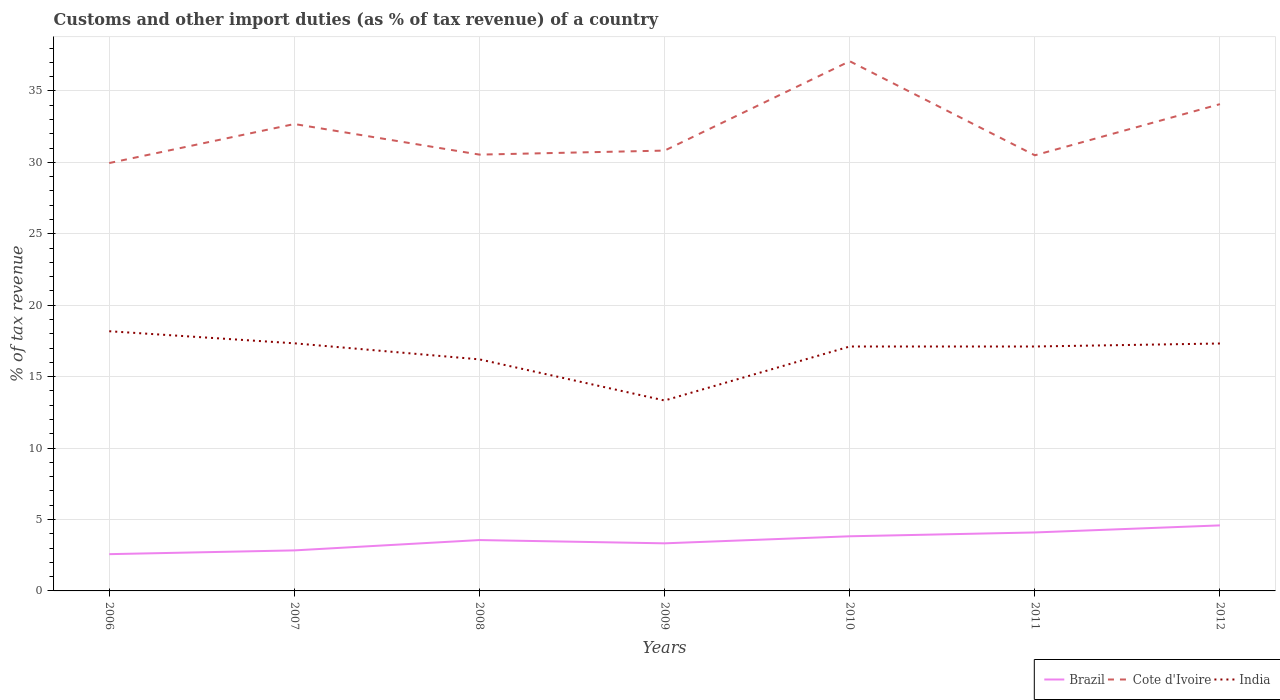Across all years, what is the maximum percentage of tax revenue from customs in Brazil?
Ensure brevity in your answer.  2.57. What is the total percentage of tax revenue from customs in Cote d'Ivoire in the graph?
Ensure brevity in your answer.  -1.39. What is the difference between the highest and the second highest percentage of tax revenue from customs in Brazil?
Provide a succinct answer. 2.01. What is the difference between two consecutive major ticks on the Y-axis?
Your response must be concise. 5. Does the graph contain any zero values?
Provide a succinct answer. No. Does the graph contain grids?
Offer a terse response. Yes. Where does the legend appear in the graph?
Offer a terse response. Bottom right. How many legend labels are there?
Ensure brevity in your answer.  3. How are the legend labels stacked?
Make the answer very short. Horizontal. What is the title of the graph?
Offer a terse response. Customs and other import duties (as % of tax revenue) of a country. What is the label or title of the Y-axis?
Keep it short and to the point. % of tax revenue. What is the % of tax revenue of Brazil in 2006?
Your answer should be very brief. 2.57. What is the % of tax revenue of Cote d'Ivoire in 2006?
Provide a short and direct response. 29.95. What is the % of tax revenue in India in 2006?
Ensure brevity in your answer.  18.18. What is the % of tax revenue in Brazil in 2007?
Your answer should be very brief. 2.84. What is the % of tax revenue in Cote d'Ivoire in 2007?
Offer a terse response. 32.68. What is the % of tax revenue of India in 2007?
Your answer should be very brief. 17.33. What is the % of tax revenue in Brazil in 2008?
Offer a very short reply. 3.56. What is the % of tax revenue of Cote d'Ivoire in 2008?
Ensure brevity in your answer.  30.54. What is the % of tax revenue in India in 2008?
Ensure brevity in your answer.  16.21. What is the % of tax revenue in Brazil in 2009?
Ensure brevity in your answer.  3.33. What is the % of tax revenue in Cote d'Ivoire in 2009?
Give a very brief answer. 30.82. What is the % of tax revenue of India in 2009?
Your answer should be very brief. 13.33. What is the % of tax revenue in Brazil in 2010?
Your answer should be very brief. 3.82. What is the % of tax revenue of Cote d'Ivoire in 2010?
Ensure brevity in your answer.  37.08. What is the % of tax revenue of India in 2010?
Your response must be concise. 17.11. What is the % of tax revenue in Brazil in 2011?
Provide a succinct answer. 4.09. What is the % of tax revenue in Cote d'Ivoire in 2011?
Give a very brief answer. 30.49. What is the % of tax revenue in India in 2011?
Your answer should be very brief. 17.11. What is the % of tax revenue in Brazil in 2012?
Provide a succinct answer. 4.59. What is the % of tax revenue in Cote d'Ivoire in 2012?
Provide a succinct answer. 34.07. What is the % of tax revenue of India in 2012?
Offer a terse response. 17.32. Across all years, what is the maximum % of tax revenue in Brazil?
Offer a very short reply. 4.59. Across all years, what is the maximum % of tax revenue in Cote d'Ivoire?
Keep it short and to the point. 37.08. Across all years, what is the maximum % of tax revenue in India?
Your answer should be very brief. 18.18. Across all years, what is the minimum % of tax revenue in Brazil?
Your answer should be compact. 2.57. Across all years, what is the minimum % of tax revenue in Cote d'Ivoire?
Provide a succinct answer. 29.95. Across all years, what is the minimum % of tax revenue in India?
Your answer should be very brief. 13.33. What is the total % of tax revenue in Brazil in the graph?
Ensure brevity in your answer.  24.8. What is the total % of tax revenue of Cote d'Ivoire in the graph?
Ensure brevity in your answer.  225.62. What is the total % of tax revenue in India in the graph?
Offer a very short reply. 116.58. What is the difference between the % of tax revenue in Brazil in 2006 and that in 2007?
Make the answer very short. -0.26. What is the difference between the % of tax revenue of Cote d'Ivoire in 2006 and that in 2007?
Make the answer very short. -2.73. What is the difference between the % of tax revenue in India in 2006 and that in 2007?
Make the answer very short. 0.85. What is the difference between the % of tax revenue of Brazil in 2006 and that in 2008?
Ensure brevity in your answer.  -0.99. What is the difference between the % of tax revenue in Cote d'Ivoire in 2006 and that in 2008?
Offer a terse response. -0.59. What is the difference between the % of tax revenue in India in 2006 and that in 2008?
Keep it short and to the point. 1.97. What is the difference between the % of tax revenue in Brazil in 2006 and that in 2009?
Offer a terse response. -0.76. What is the difference between the % of tax revenue of Cote d'Ivoire in 2006 and that in 2009?
Give a very brief answer. -0.87. What is the difference between the % of tax revenue in India in 2006 and that in 2009?
Make the answer very short. 4.85. What is the difference between the % of tax revenue in Brazil in 2006 and that in 2010?
Your response must be concise. -1.25. What is the difference between the % of tax revenue of Cote d'Ivoire in 2006 and that in 2010?
Offer a very short reply. -7.13. What is the difference between the % of tax revenue in India in 2006 and that in 2010?
Provide a succinct answer. 1.07. What is the difference between the % of tax revenue of Brazil in 2006 and that in 2011?
Your answer should be very brief. -1.52. What is the difference between the % of tax revenue of Cote d'Ivoire in 2006 and that in 2011?
Your answer should be compact. -0.54. What is the difference between the % of tax revenue in India in 2006 and that in 2011?
Your answer should be very brief. 1.07. What is the difference between the % of tax revenue of Brazil in 2006 and that in 2012?
Your response must be concise. -2.01. What is the difference between the % of tax revenue of Cote d'Ivoire in 2006 and that in 2012?
Provide a succinct answer. -4.12. What is the difference between the % of tax revenue in India in 2006 and that in 2012?
Provide a short and direct response. 0.86. What is the difference between the % of tax revenue of Brazil in 2007 and that in 2008?
Give a very brief answer. -0.72. What is the difference between the % of tax revenue in Cote d'Ivoire in 2007 and that in 2008?
Provide a succinct answer. 2.14. What is the difference between the % of tax revenue of India in 2007 and that in 2008?
Provide a succinct answer. 1.12. What is the difference between the % of tax revenue in Brazil in 2007 and that in 2009?
Make the answer very short. -0.49. What is the difference between the % of tax revenue of Cote d'Ivoire in 2007 and that in 2009?
Give a very brief answer. 1.86. What is the difference between the % of tax revenue in India in 2007 and that in 2009?
Ensure brevity in your answer.  4. What is the difference between the % of tax revenue in Brazil in 2007 and that in 2010?
Offer a terse response. -0.99. What is the difference between the % of tax revenue in Cote d'Ivoire in 2007 and that in 2010?
Keep it short and to the point. -4.4. What is the difference between the % of tax revenue of India in 2007 and that in 2010?
Keep it short and to the point. 0.22. What is the difference between the % of tax revenue of Brazil in 2007 and that in 2011?
Your response must be concise. -1.26. What is the difference between the % of tax revenue of Cote d'Ivoire in 2007 and that in 2011?
Give a very brief answer. 2.19. What is the difference between the % of tax revenue in India in 2007 and that in 2011?
Offer a terse response. 0.22. What is the difference between the % of tax revenue in Brazil in 2007 and that in 2012?
Your answer should be compact. -1.75. What is the difference between the % of tax revenue in Cote d'Ivoire in 2007 and that in 2012?
Give a very brief answer. -1.39. What is the difference between the % of tax revenue of India in 2007 and that in 2012?
Your answer should be very brief. 0.01. What is the difference between the % of tax revenue of Brazil in 2008 and that in 2009?
Your answer should be very brief. 0.23. What is the difference between the % of tax revenue in Cote d'Ivoire in 2008 and that in 2009?
Your response must be concise. -0.28. What is the difference between the % of tax revenue in India in 2008 and that in 2009?
Provide a short and direct response. 2.88. What is the difference between the % of tax revenue in Brazil in 2008 and that in 2010?
Provide a short and direct response. -0.26. What is the difference between the % of tax revenue in Cote d'Ivoire in 2008 and that in 2010?
Your response must be concise. -6.54. What is the difference between the % of tax revenue of India in 2008 and that in 2010?
Ensure brevity in your answer.  -0.9. What is the difference between the % of tax revenue of Brazil in 2008 and that in 2011?
Your answer should be compact. -0.53. What is the difference between the % of tax revenue of Cote d'Ivoire in 2008 and that in 2011?
Give a very brief answer. 0.05. What is the difference between the % of tax revenue in India in 2008 and that in 2011?
Your answer should be very brief. -0.9. What is the difference between the % of tax revenue in Brazil in 2008 and that in 2012?
Your answer should be very brief. -1.03. What is the difference between the % of tax revenue in Cote d'Ivoire in 2008 and that in 2012?
Offer a very short reply. -3.53. What is the difference between the % of tax revenue of India in 2008 and that in 2012?
Offer a terse response. -1.11. What is the difference between the % of tax revenue of Brazil in 2009 and that in 2010?
Make the answer very short. -0.49. What is the difference between the % of tax revenue of Cote d'Ivoire in 2009 and that in 2010?
Offer a very short reply. -6.26. What is the difference between the % of tax revenue in India in 2009 and that in 2010?
Give a very brief answer. -3.78. What is the difference between the % of tax revenue of Brazil in 2009 and that in 2011?
Ensure brevity in your answer.  -0.76. What is the difference between the % of tax revenue in Cote d'Ivoire in 2009 and that in 2011?
Give a very brief answer. 0.33. What is the difference between the % of tax revenue in India in 2009 and that in 2011?
Your answer should be very brief. -3.78. What is the difference between the % of tax revenue of Brazil in 2009 and that in 2012?
Provide a succinct answer. -1.26. What is the difference between the % of tax revenue of Cote d'Ivoire in 2009 and that in 2012?
Your response must be concise. -3.25. What is the difference between the % of tax revenue of India in 2009 and that in 2012?
Your answer should be very brief. -3.99. What is the difference between the % of tax revenue in Brazil in 2010 and that in 2011?
Make the answer very short. -0.27. What is the difference between the % of tax revenue of Cote d'Ivoire in 2010 and that in 2011?
Offer a terse response. 6.58. What is the difference between the % of tax revenue in Brazil in 2010 and that in 2012?
Provide a succinct answer. -0.76. What is the difference between the % of tax revenue of Cote d'Ivoire in 2010 and that in 2012?
Your response must be concise. 3. What is the difference between the % of tax revenue in India in 2010 and that in 2012?
Provide a succinct answer. -0.21. What is the difference between the % of tax revenue of Brazil in 2011 and that in 2012?
Offer a very short reply. -0.49. What is the difference between the % of tax revenue of Cote d'Ivoire in 2011 and that in 2012?
Provide a succinct answer. -3.58. What is the difference between the % of tax revenue of India in 2011 and that in 2012?
Ensure brevity in your answer.  -0.21. What is the difference between the % of tax revenue of Brazil in 2006 and the % of tax revenue of Cote d'Ivoire in 2007?
Your response must be concise. -30.11. What is the difference between the % of tax revenue of Brazil in 2006 and the % of tax revenue of India in 2007?
Make the answer very short. -14.76. What is the difference between the % of tax revenue of Cote d'Ivoire in 2006 and the % of tax revenue of India in 2007?
Offer a terse response. 12.62. What is the difference between the % of tax revenue of Brazil in 2006 and the % of tax revenue of Cote d'Ivoire in 2008?
Your answer should be compact. -27.96. What is the difference between the % of tax revenue of Brazil in 2006 and the % of tax revenue of India in 2008?
Your answer should be very brief. -13.63. What is the difference between the % of tax revenue in Cote d'Ivoire in 2006 and the % of tax revenue in India in 2008?
Provide a short and direct response. 13.74. What is the difference between the % of tax revenue of Brazil in 2006 and the % of tax revenue of Cote d'Ivoire in 2009?
Provide a short and direct response. -28.25. What is the difference between the % of tax revenue of Brazil in 2006 and the % of tax revenue of India in 2009?
Your answer should be very brief. -10.76. What is the difference between the % of tax revenue of Cote d'Ivoire in 2006 and the % of tax revenue of India in 2009?
Provide a succinct answer. 16.62. What is the difference between the % of tax revenue in Brazil in 2006 and the % of tax revenue in Cote d'Ivoire in 2010?
Your answer should be very brief. -34.5. What is the difference between the % of tax revenue of Brazil in 2006 and the % of tax revenue of India in 2010?
Provide a short and direct response. -14.53. What is the difference between the % of tax revenue of Cote d'Ivoire in 2006 and the % of tax revenue of India in 2010?
Offer a very short reply. 12.84. What is the difference between the % of tax revenue in Brazil in 2006 and the % of tax revenue in Cote d'Ivoire in 2011?
Make the answer very short. -27.92. What is the difference between the % of tax revenue in Brazil in 2006 and the % of tax revenue in India in 2011?
Provide a succinct answer. -14.53. What is the difference between the % of tax revenue of Cote d'Ivoire in 2006 and the % of tax revenue of India in 2011?
Your answer should be compact. 12.84. What is the difference between the % of tax revenue of Brazil in 2006 and the % of tax revenue of Cote d'Ivoire in 2012?
Offer a terse response. -31.5. What is the difference between the % of tax revenue in Brazil in 2006 and the % of tax revenue in India in 2012?
Your answer should be compact. -14.74. What is the difference between the % of tax revenue in Cote d'Ivoire in 2006 and the % of tax revenue in India in 2012?
Give a very brief answer. 12.63. What is the difference between the % of tax revenue in Brazil in 2007 and the % of tax revenue in Cote d'Ivoire in 2008?
Make the answer very short. -27.7. What is the difference between the % of tax revenue in Brazil in 2007 and the % of tax revenue in India in 2008?
Your answer should be compact. -13.37. What is the difference between the % of tax revenue of Cote d'Ivoire in 2007 and the % of tax revenue of India in 2008?
Give a very brief answer. 16.47. What is the difference between the % of tax revenue in Brazil in 2007 and the % of tax revenue in Cote d'Ivoire in 2009?
Offer a very short reply. -27.98. What is the difference between the % of tax revenue of Brazil in 2007 and the % of tax revenue of India in 2009?
Your response must be concise. -10.49. What is the difference between the % of tax revenue in Cote d'Ivoire in 2007 and the % of tax revenue in India in 2009?
Make the answer very short. 19.35. What is the difference between the % of tax revenue in Brazil in 2007 and the % of tax revenue in Cote d'Ivoire in 2010?
Your response must be concise. -34.24. What is the difference between the % of tax revenue of Brazil in 2007 and the % of tax revenue of India in 2010?
Keep it short and to the point. -14.27. What is the difference between the % of tax revenue in Cote d'Ivoire in 2007 and the % of tax revenue in India in 2010?
Your response must be concise. 15.57. What is the difference between the % of tax revenue in Brazil in 2007 and the % of tax revenue in Cote d'Ivoire in 2011?
Ensure brevity in your answer.  -27.65. What is the difference between the % of tax revenue in Brazil in 2007 and the % of tax revenue in India in 2011?
Provide a succinct answer. -14.27. What is the difference between the % of tax revenue of Cote d'Ivoire in 2007 and the % of tax revenue of India in 2011?
Provide a short and direct response. 15.57. What is the difference between the % of tax revenue of Brazil in 2007 and the % of tax revenue of Cote d'Ivoire in 2012?
Provide a short and direct response. -31.23. What is the difference between the % of tax revenue in Brazil in 2007 and the % of tax revenue in India in 2012?
Ensure brevity in your answer.  -14.48. What is the difference between the % of tax revenue of Cote d'Ivoire in 2007 and the % of tax revenue of India in 2012?
Your answer should be very brief. 15.36. What is the difference between the % of tax revenue in Brazil in 2008 and the % of tax revenue in Cote d'Ivoire in 2009?
Make the answer very short. -27.26. What is the difference between the % of tax revenue in Brazil in 2008 and the % of tax revenue in India in 2009?
Give a very brief answer. -9.77. What is the difference between the % of tax revenue in Cote d'Ivoire in 2008 and the % of tax revenue in India in 2009?
Make the answer very short. 17.21. What is the difference between the % of tax revenue in Brazil in 2008 and the % of tax revenue in Cote d'Ivoire in 2010?
Keep it short and to the point. -33.52. What is the difference between the % of tax revenue in Brazil in 2008 and the % of tax revenue in India in 2010?
Give a very brief answer. -13.55. What is the difference between the % of tax revenue in Cote d'Ivoire in 2008 and the % of tax revenue in India in 2010?
Offer a terse response. 13.43. What is the difference between the % of tax revenue of Brazil in 2008 and the % of tax revenue of Cote d'Ivoire in 2011?
Offer a terse response. -26.93. What is the difference between the % of tax revenue of Brazil in 2008 and the % of tax revenue of India in 2011?
Keep it short and to the point. -13.55. What is the difference between the % of tax revenue in Cote d'Ivoire in 2008 and the % of tax revenue in India in 2011?
Keep it short and to the point. 13.43. What is the difference between the % of tax revenue in Brazil in 2008 and the % of tax revenue in Cote d'Ivoire in 2012?
Provide a succinct answer. -30.51. What is the difference between the % of tax revenue of Brazil in 2008 and the % of tax revenue of India in 2012?
Offer a very short reply. -13.76. What is the difference between the % of tax revenue of Cote d'Ivoire in 2008 and the % of tax revenue of India in 2012?
Your response must be concise. 13.22. What is the difference between the % of tax revenue of Brazil in 2009 and the % of tax revenue of Cote d'Ivoire in 2010?
Provide a succinct answer. -33.74. What is the difference between the % of tax revenue in Brazil in 2009 and the % of tax revenue in India in 2010?
Make the answer very short. -13.78. What is the difference between the % of tax revenue of Cote d'Ivoire in 2009 and the % of tax revenue of India in 2010?
Your answer should be compact. 13.71. What is the difference between the % of tax revenue in Brazil in 2009 and the % of tax revenue in Cote d'Ivoire in 2011?
Keep it short and to the point. -27.16. What is the difference between the % of tax revenue in Brazil in 2009 and the % of tax revenue in India in 2011?
Provide a succinct answer. -13.78. What is the difference between the % of tax revenue in Cote d'Ivoire in 2009 and the % of tax revenue in India in 2011?
Provide a short and direct response. 13.71. What is the difference between the % of tax revenue of Brazil in 2009 and the % of tax revenue of Cote d'Ivoire in 2012?
Your answer should be very brief. -30.74. What is the difference between the % of tax revenue of Brazil in 2009 and the % of tax revenue of India in 2012?
Ensure brevity in your answer.  -13.99. What is the difference between the % of tax revenue of Cote d'Ivoire in 2009 and the % of tax revenue of India in 2012?
Provide a succinct answer. 13.5. What is the difference between the % of tax revenue in Brazil in 2010 and the % of tax revenue in Cote d'Ivoire in 2011?
Offer a very short reply. -26.67. What is the difference between the % of tax revenue of Brazil in 2010 and the % of tax revenue of India in 2011?
Your response must be concise. -13.28. What is the difference between the % of tax revenue of Cote d'Ivoire in 2010 and the % of tax revenue of India in 2011?
Provide a short and direct response. 19.97. What is the difference between the % of tax revenue of Brazil in 2010 and the % of tax revenue of Cote d'Ivoire in 2012?
Your answer should be compact. -30.25. What is the difference between the % of tax revenue of Brazil in 2010 and the % of tax revenue of India in 2012?
Ensure brevity in your answer.  -13.49. What is the difference between the % of tax revenue in Cote d'Ivoire in 2010 and the % of tax revenue in India in 2012?
Provide a short and direct response. 19.76. What is the difference between the % of tax revenue of Brazil in 2011 and the % of tax revenue of Cote d'Ivoire in 2012?
Your answer should be compact. -29.98. What is the difference between the % of tax revenue in Brazil in 2011 and the % of tax revenue in India in 2012?
Your answer should be very brief. -13.23. What is the difference between the % of tax revenue of Cote d'Ivoire in 2011 and the % of tax revenue of India in 2012?
Make the answer very short. 13.17. What is the average % of tax revenue of Brazil per year?
Keep it short and to the point. 3.54. What is the average % of tax revenue in Cote d'Ivoire per year?
Provide a succinct answer. 32.23. What is the average % of tax revenue of India per year?
Keep it short and to the point. 16.65. In the year 2006, what is the difference between the % of tax revenue of Brazil and % of tax revenue of Cote d'Ivoire?
Provide a short and direct response. -27.37. In the year 2006, what is the difference between the % of tax revenue in Brazil and % of tax revenue in India?
Keep it short and to the point. -15.6. In the year 2006, what is the difference between the % of tax revenue in Cote d'Ivoire and % of tax revenue in India?
Offer a very short reply. 11.77. In the year 2007, what is the difference between the % of tax revenue of Brazil and % of tax revenue of Cote d'Ivoire?
Make the answer very short. -29.84. In the year 2007, what is the difference between the % of tax revenue of Brazil and % of tax revenue of India?
Provide a short and direct response. -14.49. In the year 2007, what is the difference between the % of tax revenue of Cote d'Ivoire and % of tax revenue of India?
Your answer should be very brief. 15.35. In the year 2008, what is the difference between the % of tax revenue in Brazil and % of tax revenue in Cote d'Ivoire?
Your answer should be very brief. -26.98. In the year 2008, what is the difference between the % of tax revenue of Brazil and % of tax revenue of India?
Provide a short and direct response. -12.65. In the year 2008, what is the difference between the % of tax revenue of Cote d'Ivoire and % of tax revenue of India?
Make the answer very short. 14.33. In the year 2009, what is the difference between the % of tax revenue in Brazil and % of tax revenue in Cote d'Ivoire?
Offer a very short reply. -27.49. In the year 2009, what is the difference between the % of tax revenue of Brazil and % of tax revenue of India?
Your answer should be compact. -10. In the year 2009, what is the difference between the % of tax revenue of Cote d'Ivoire and % of tax revenue of India?
Provide a short and direct response. 17.49. In the year 2010, what is the difference between the % of tax revenue in Brazil and % of tax revenue in Cote d'Ivoire?
Keep it short and to the point. -33.25. In the year 2010, what is the difference between the % of tax revenue of Brazil and % of tax revenue of India?
Keep it short and to the point. -13.28. In the year 2010, what is the difference between the % of tax revenue of Cote d'Ivoire and % of tax revenue of India?
Provide a short and direct response. 19.97. In the year 2011, what is the difference between the % of tax revenue in Brazil and % of tax revenue in Cote d'Ivoire?
Your response must be concise. -26.4. In the year 2011, what is the difference between the % of tax revenue of Brazil and % of tax revenue of India?
Provide a succinct answer. -13.02. In the year 2011, what is the difference between the % of tax revenue of Cote d'Ivoire and % of tax revenue of India?
Your answer should be compact. 13.38. In the year 2012, what is the difference between the % of tax revenue of Brazil and % of tax revenue of Cote d'Ivoire?
Ensure brevity in your answer.  -29.48. In the year 2012, what is the difference between the % of tax revenue of Brazil and % of tax revenue of India?
Your answer should be very brief. -12.73. In the year 2012, what is the difference between the % of tax revenue of Cote d'Ivoire and % of tax revenue of India?
Provide a short and direct response. 16.75. What is the ratio of the % of tax revenue of Brazil in 2006 to that in 2007?
Your answer should be compact. 0.91. What is the ratio of the % of tax revenue in Cote d'Ivoire in 2006 to that in 2007?
Ensure brevity in your answer.  0.92. What is the ratio of the % of tax revenue in India in 2006 to that in 2007?
Your response must be concise. 1.05. What is the ratio of the % of tax revenue in Brazil in 2006 to that in 2008?
Keep it short and to the point. 0.72. What is the ratio of the % of tax revenue in Cote d'Ivoire in 2006 to that in 2008?
Keep it short and to the point. 0.98. What is the ratio of the % of tax revenue of India in 2006 to that in 2008?
Provide a short and direct response. 1.12. What is the ratio of the % of tax revenue in Brazil in 2006 to that in 2009?
Offer a very short reply. 0.77. What is the ratio of the % of tax revenue in Cote d'Ivoire in 2006 to that in 2009?
Your answer should be compact. 0.97. What is the ratio of the % of tax revenue of India in 2006 to that in 2009?
Provide a succinct answer. 1.36. What is the ratio of the % of tax revenue of Brazil in 2006 to that in 2010?
Offer a terse response. 0.67. What is the ratio of the % of tax revenue of Cote d'Ivoire in 2006 to that in 2010?
Your response must be concise. 0.81. What is the ratio of the % of tax revenue in India in 2006 to that in 2010?
Give a very brief answer. 1.06. What is the ratio of the % of tax revenue in Brazil in 2006 to that in 2011?
Your answer should be compact. 0.63. What is the ratio of the % of tax revenue of Cote d'Ivoire in 2006 to that in 2011?
Give a very brief answer. 0.98. What is the ratio of the % of tax revenue of India in 2006 to that in 2011?
Keep it short and to the point. 1.06. What is the ratio of the % of tax revenue in Brazil in 2006 to that in 2012?
Your answer should be very brief. 0.56. What is the ratio of the % of tax revenue in Cote d'Ivoire in 2006 to that in 2012?
Your answer should be very brief. 0.88. What is the ratio of the % of tax revenue of India in 2006 to that in 2012?
Provide a short and direct response. 1.05. What is the ratio of the % of tax revenue of Brazil in 2007 to that in 2008?
Keep it short and to the point. 0.8. What is the ratio of the % of tax revenue in Cote d'Ivoire in 2007 to that in 2008?
Your answer should be compact. 1.07. What is the ratio of the % of tax revenue in India in 2007 to that in 2008?
Make the answer very short. 1.07. What is the ratio of the % of tax revenue of Brazil in 2007 to that in 2009?
Provide a short and direct response. 0.85. What is the ratio of the % of tax revenue of Cote d'Ivoire in 2007 to that in 2009?
Keep it short and to the point. 1.06. What is the ratio of the % of tax revenue of India in 2007 to that in 2009?
Provide a short and direct response. 1.3. What is the ratio of the % of tax revenue of Brazil in 2007 to that in 2010?
Provide a succinct answer. 0.74. What is the ratio of the % of tax revenue of Cote d'Ivoire in 2007 to that in 2010?
Your answer should be very brief. 0.88. What is the ratio of the % of tax revenue in India in 2007 to that in 2010?
Make the answer very short. 1.01. What is the ratio of the % of tax revenue in Brazil in 2007 to that in 2011?
Your answer should be very brief. 0.69. What is the ratio of the % of tax revenue of Cote d'Ivoire in 2007 to that in 2011?
Provide a succinct answer. 1.07. What is the ratio of the % of tax revenue in Brazil in 2007 to that in 2012?
Your answer should be very brief. 0.62. What is the ratio of the % of tax revenue of Cote d'Ivoire in 2007 to that in 2012?
Provide a short and direct response. 0.96. What is the ratio of the % of tax revenue of India in 2007 to that in 2012?
Keep it short and to the point. 1. What is the ratio of the % of tax revenue of Brazil in 2008 to that in 2009?
Your answer should be very brief. 1.07. What is the ratio of the % of tax revenue in Cote d'Ivoire in 2008 to that in 2009?
Give a very brief answer. 0.99. What is the ratio of the % of tax revenue in India in 2008 to that in 2009?
Your answer should be very brief. 1.22. What is the ratio of the % of tax revenue of Brazil in 2008 to that in 2010?
Make the answer very short. 0.93. What is the ratio of the % of tax revenue of Cote d'Ivoire in 2008 to that in 2010?
Keep it short and to the point. 0.82. What is the ratio of the % of tax revenue of India in 2008 to that in 2010?
Ensure brevity in your answer.  0.95. What is the ratio of the % of tax revenue of Brazil in 2008 to that in 2011?
Give a very brief answer. 0.87. What is the ratio of the % of tax revenue in India in 2008 to that in 2011?
Offer a terse response. 0.95. What is the ratio of the % of tax revenue of Brazil in 2008 to that in 2012?
Give a very brief answer. 0.78. What is the ratio of the % of tax revenue of Cote d'Ivoire in 2008 to that in 2012?
Ensure brevity in your answer.  0.9. What is the ratio of the % of tax revenue in India in 2008 to that in 2012?
Provide a short and direct response. 0.94. What is the ratio of the % of tax revenue of Brazil in 2009 to that in 2010?
Give a very brief answer. 0.87. What is the ratio of the % of tax revenue in Cote d'Ivoire in 2009 to that in 2010?
Keep it short and to the point. 0.83. What is the ratio of the % of tax revenue in India in 2009 to that in 2010?
Give a very brief answer. 0.78. What is the ratio of the % of tax revenue of Brazil in 2009 to that in 2011?
Ensure brevity in your answer.  0.81. What is the ratio of the % of tax revenue in Cote d'Ivoire in 2009 to that in 2011?
Ensure brevity in your answer.  1.01. What is the ratio of the % of tax revenue of India in 2009 to that in 2011?
Make the answer very short. 0.78. What is the ratio of the % of tax revenue in Brazil in 2009 to that in 2012?
Provide a succinct answer. 0.73. What is the ratio of the % of tax revenue of Cote d'Ivoire in 2009 to that in 2012?
Make the answer very short. 0.9. What is the ratio of the % of tax revenue of India in 2009 to that in 2012?
Offer a very short reply. 0.77. What is the ratio of the % of tax revenue in Brazil in 2010 to that in 2011?
Your answer should be very brief. 0.93. What is the ratio of the % of tax revenue of Cote d'Ivoire in 2010 to that in 2011?
Your answer should be very brief. 1.22. What is the ratio of the % of tax revenue of India in 2010 to that in 2011?
Your answer should be compact. 1. What is the ratio of the % of tax revenue in Brazil in 2010 to that in 2012?
Your response must be concise. 0.83. What is the ratio of the % of tax revenue in Cote d'Ivoire in 2010 to that in 2012?
Ensure brevity in your answer.  1.09. What is the ratio of the % of tax revenue of India in 2010 to that in 2012?
Your response must be concise. 0.99. What is the ratio of the % of tax revenue in Brazil in 2011 to that in 2012?
Your answer should be compact. 0.89. What is the ratio of the % of tax revenue of Cote d'Ivoire in 2011 to that in 2012?
Offer a very short reply. 0.89. What is the ratio of the % of tax revenue of India in 2011 to that in 2012?
Give a very brief answer. 0.99. What is the difference between the highest and the second highest % of tax revenue in Brazil?
Make the answer very short. 0.49. What is the difference between the highest and the second highest % of tax revenue of Cote d'Ivoire?
Provide a succinct answer. 3. What is the difference between the highest and the second highest % of tax revenue of India?
Offer a very short reply. 0.85. What is the difference between the highest and the lowest % of tax revenue of Brazil?
Provide a succinct answer. 2.01. What is the difference between the highest and the lowest % of tax revenue of Cote d'Ivoire?
Make the answer very short. 7.13. What is the difference between the highest and the lowest % of tax revenue in India?
Give a very brief answer. 4.85. 